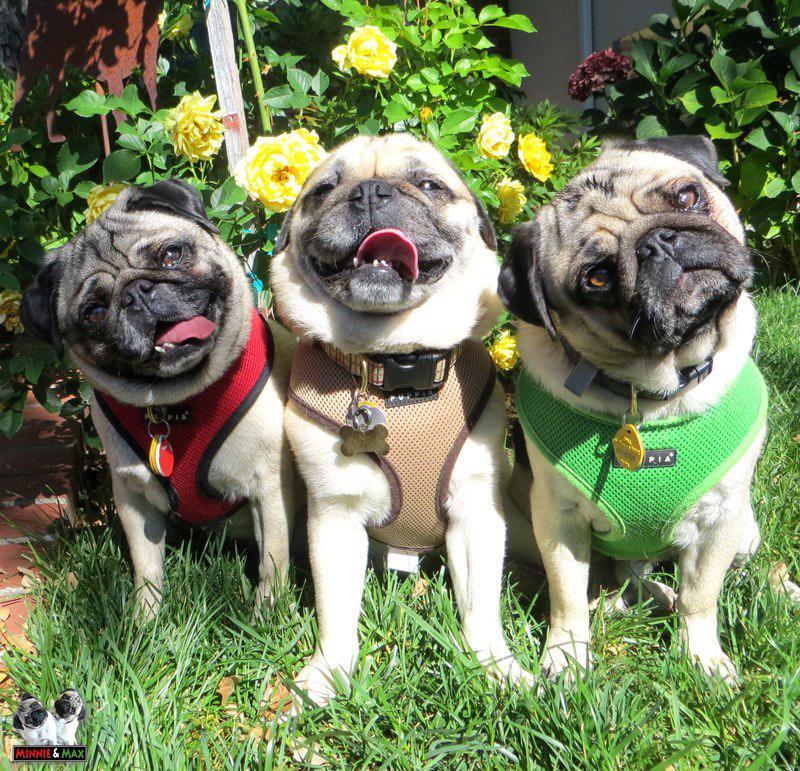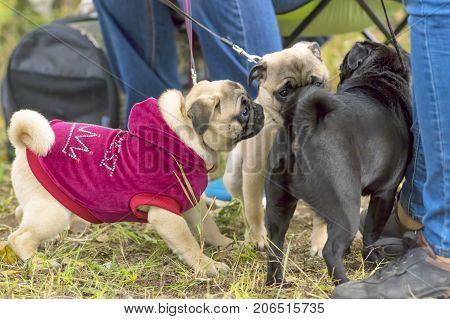The first image is the image on the left, the second image is the image on the right. For the images shown, is this caption "One of the four pugs is wearing a hat." true? Answer yes or no. No. The first image is the image on the left, the second image is the image on the right. Assess this claim about the two images: "The right image includes at least one standing beige pug on a leash, and the left image features three forward-facing beige pugs wearing some type of attire.". Correct or not? Answer yes or no. Yes. 